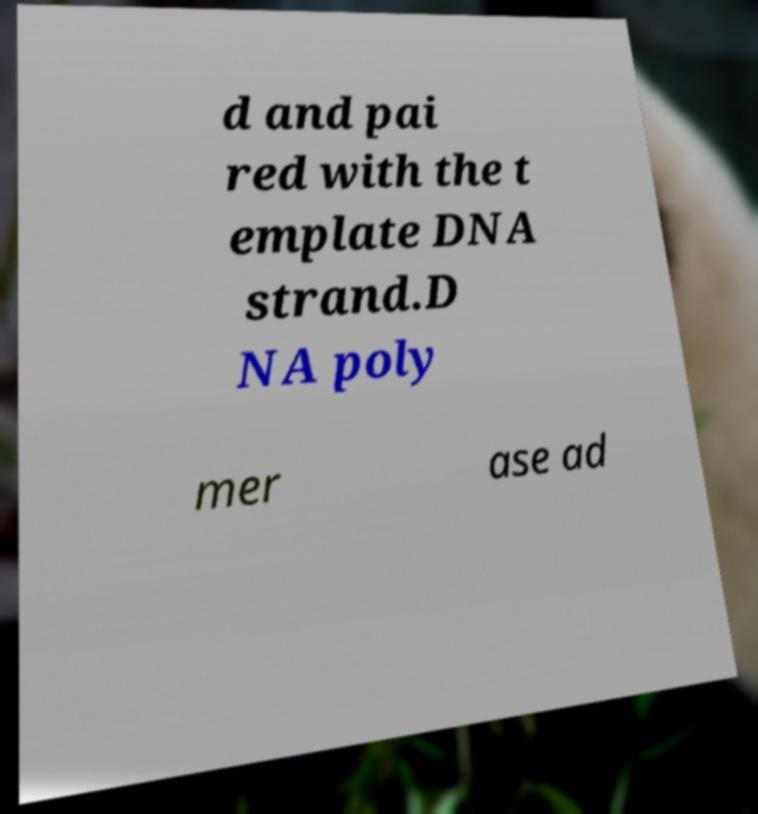Can you read and provide the text displayed in the image?This photo seems to have some interesting text. Can you extract and type it out for me? d and pai red with the t emplate DNA strand.D NA poly mer ase ad 